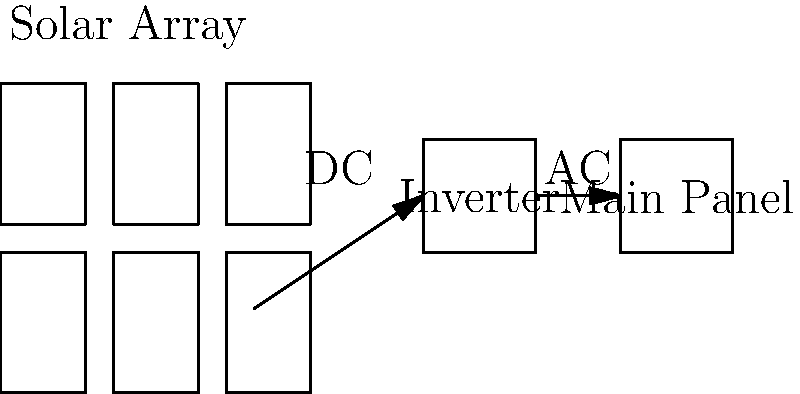As part of your green energy initiative, you're reviewing a solar panel installation schematic for a public building. The diagram shows a 3x2 solar panel array connected to an inverter, which then connects to the main panel. What is the primary function of the inverter in this system, and why is it crucial for the building's electrical infrastructure? To understand the role of the inverter in this solar panel system, let's break down the components and their functions:

1. Solar Array: The 3x2 grid of solar panels converts sunlight into electrical energy. However, this energy is produced as Direct Current (DC).

2. Inverter: This is the key component in question. Its primary functions are:
   a) Convert DC to AC: Solar panels produce DC, but most buildings use AC power.
   b) Synchronize with the grid: Ensures the generated power matches the frequency and phase of the utility grid.
   c) Optimize power output: Many inverters include Maximum Power Point Tracking (MPPT) to maximize energy production.
   d) Safety features: Includes anti-islanding protection to prevent backfeeding during power outages.

3. Main Panel: This is where the converted AC power is fed into the building's electrical system.

The inverter is crucial because:
1. Most household and commercial appliances run on AC power, not the DC produced by solar panels.
2. The electrical grid operates on AC, so for grid-tied systems, the power must be in AC form.
3. It allows for bidirectional power flow, enabling excess energy to be fed back into the grid if allowed by local regulations.
4. It provides a point of control and monitoring for the solar power system.

Without the inverter, the DC power from the solar panels would not be usable in the building's standard electrical infrastructure, rendering the entire solar installation ineffective for powering the building or connecting to the grid.
Answer: Convert DC to AC and synchronize with the grid 